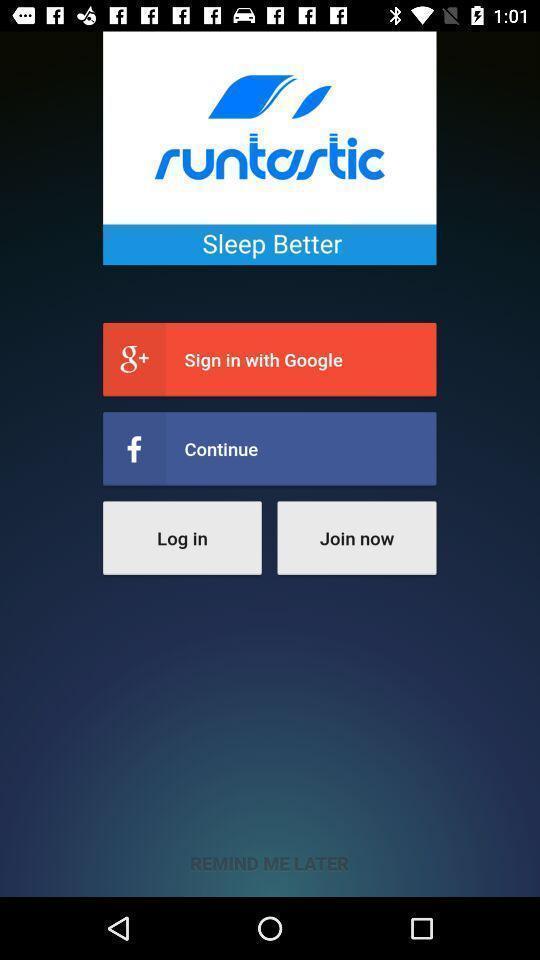What is the overall content of this screenshot? Welcome page for a sleep app. 